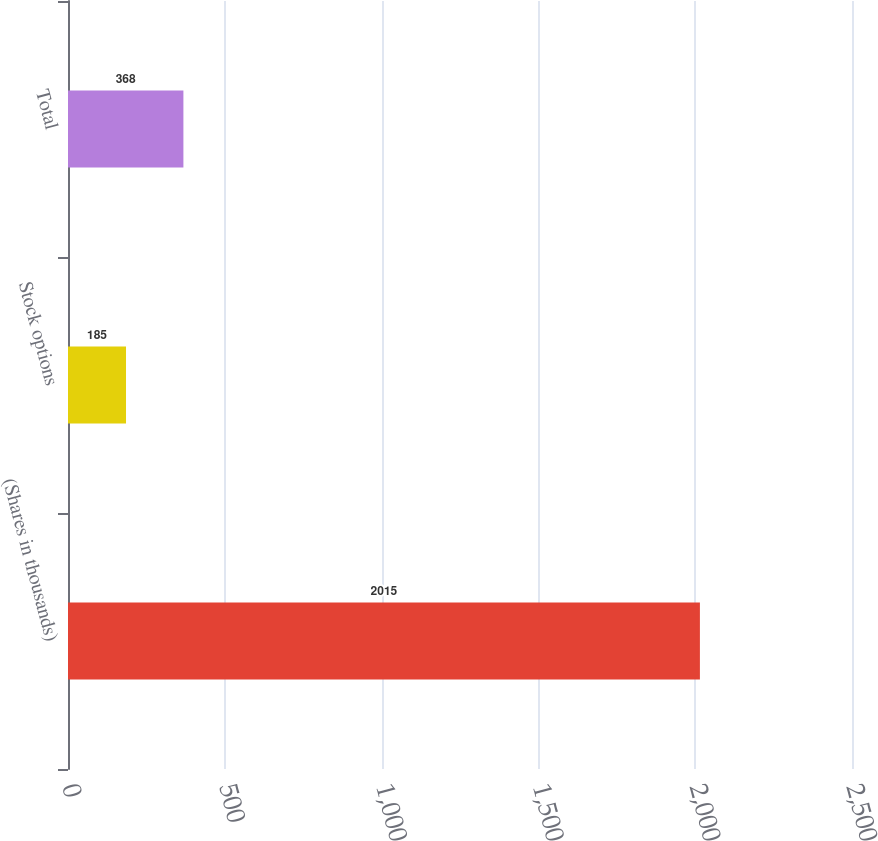Convert chart. <chart><loc_0><loc_0><loc_500><loc_500><bar_chart><fcel>(Shares in thousands)<fcel>Stock options<fcel>Total<nl><fcel>2015<fcel>185<fcel>368<nl></chart> 